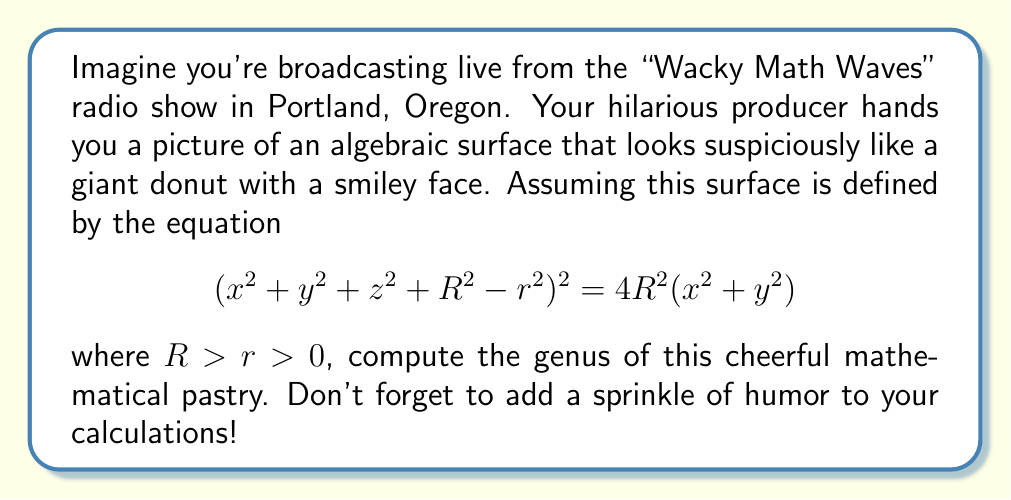Show me your answer to this math problem. Alright, folks, let's dive into this delicious mathematical conundrum! Here's how we'll tackle this sweet problem:

1) First, let's recognize that our equation describes a torus (fancy math speak for "donut"). The smiley face is just icing on the cake... or should I say, frosting on the donut?

2) For a surface defined by a polynomial equation $F(x,y,z)=0$ of degree $d$, the genus $g$ is given by the formula:

   $$g = \frac{(d-1)(d-2)(d-3)}{6}$$

3) Our equation can be rearranged as:
   $$(x^2+y^2+z^2+R^2-r^2)^2 - 4R^2(x^2+y^2) = 0$$

4) This is a polynomial of degree 4 in $x$, $y$, and $z$. So, $d=4$.

5) Plugging this into our formula:

   $$g = \frac{(4-1)(4-2)(4-3)}{6} = \frac{3 \cdot 2 \cdot 1}{6} = 1$$

6) And there you have it! Our cheerful donut has a genus of 1, which in topological terms means it has one "hole". 

Remember, listeners, in the world of donuts and math, it's all about the hole truth and nothing but the truth!
Answer: $1$ 